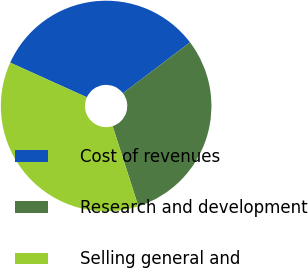<chart> <loc_0><loc_0><loc_500><loc_500><pie_chart><fcel>Cost of revenues<fcel>Research and development<fcel>Selling general and<nl><fcel>32.91%<fcel>30.38%<fcel>36.71%<nl></chart> 